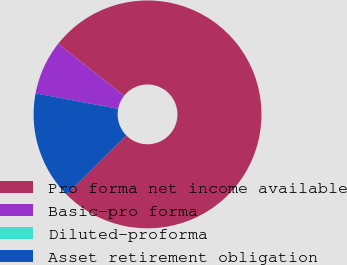<chart> <loc_0><loc_0><loc_500><loc_500><pie_chart><fcel>Pro forma net income available<fcel>Basic-pro forma<fcel>Diluted-proforma<fcel>Asset retirement obligation<nl><fcel>76.92%<fcel>7.69%<fcel>0.0%<fcel>15.38%<nl></chart> 